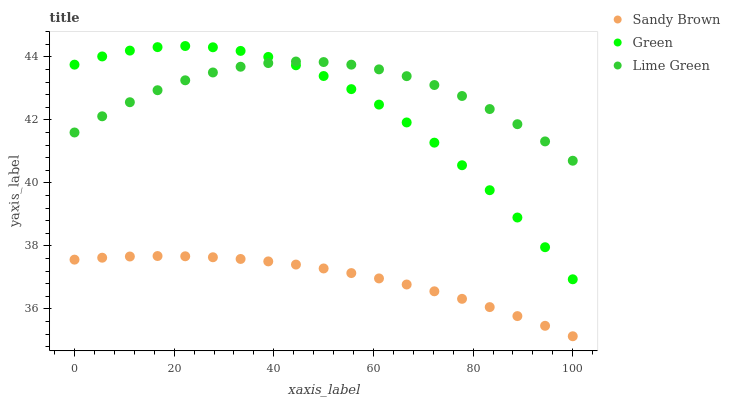Does Sandy Brown have the minimum area under the curve?
Answer yes or no. Yes. Does Lime Green have the maximum area under the curve?
Answer yes or no. Yes. Does Lime Green have the minimum area under the curve?
Answer yes or no. No. Does Sandy Brown have the maximum area under the curve?
Answer yes or no. No. Is Sandy Brown the smoothest?
Answer yes or no. Yes. Is Green the roughest?
Answer yes or no. Yes. Is Lime Green the smoothest?
Answer yes or no. No. Is Lime Green the roughest?
Answer yes or no. No. Does Sandy Brown have the lowest value?
Answer yes or no. Yes. Does Lime Green have the lowest value?
Answer yes or no. No. Does Green have the highest value?
Answer yes or no. Yes. Does Lime Green have the highest value?
Answer yes or no. No. Is Sandy Brown less than Lime Green?
Answer yes or no. Yes. Is Green greater than Sandy Brown?
Answer yes or no. Yes. Does Lime Green intersect Green?
Answer yes or no. Yes. Is Lime Green less than Green?
Answer yes or no. No. Is Lime Green greater than Green?
Answer yes or no. No. Does Sandy Brown intersect Lime Green?
Answer yes or no. No. 